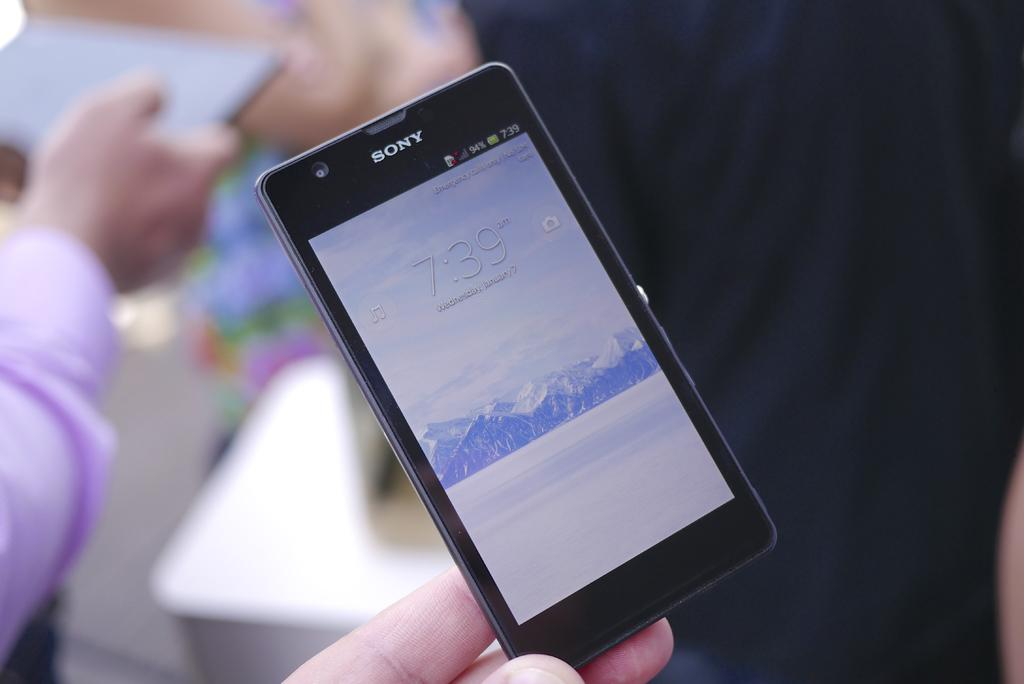<image>
Provide a brief description of the given image. A Sony smartphone being lightly grasped by a person while they are viewing the lock screen 